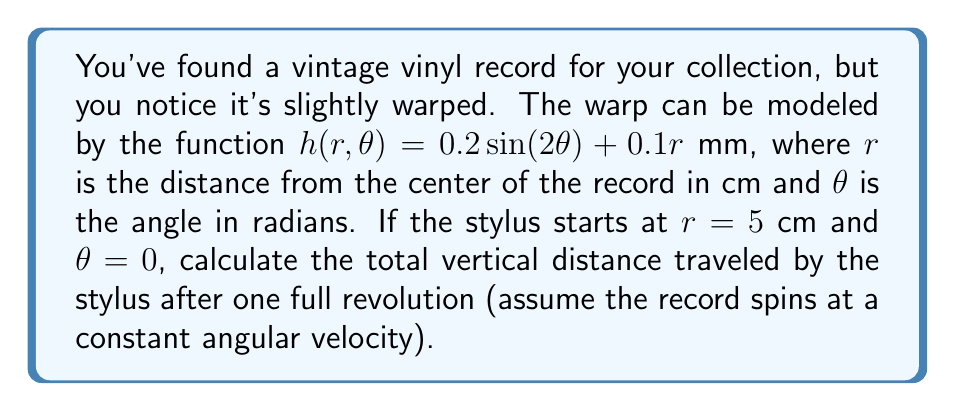Solve this math problem. Let's approach this step-by-step:

1) The stylus follows the surface of the record, which is described by the function:
   $$h(r, \theta) = 0.2 \sin(2\theta) + 0.1r$$

2) We're interested in one full revolution, so $\theta$ will go from 0 to $2\pi$.

3) The radius $r$ remains constant at 5 cm during the revolution.

4) To find the total vertical distance, we need to calculate the total absolute change in height. This can be done by integrating the absolute value of the derivative of $h$ with respect to $\theta$:

   $$\text{Total vertical distance} = \int_0^{2\pi} \left|\frac{\partial h}{\partial \theta}\right| d\theta$$

5) Let's calculate $\frac{\partial h}{\partial \theta}$:
   $$\frac{\partial h}{\partial \theta} = 0.4 \cos(2\theta)$$

6) Now our integral becomes:
   $$\int_0^{2\pi} |0.4 \cos(2\theta)| d\theta$$

7) This integral can be solved by breaking it into four parts where $\cos(2\theta)$ is positive or negative:
   $$4 \int_0^{\pi/4} 0.4 \cos(2\theta) d\theta = 4 \cdot 0.4 \cdot \frac{1}{2} \cdot \frac{\pi}{4} = 0.8\pi$$

8) Therefore, the total vertical distance traveled is $0.8\pi$ mm.
Answer: $0.8\pi$ mm 